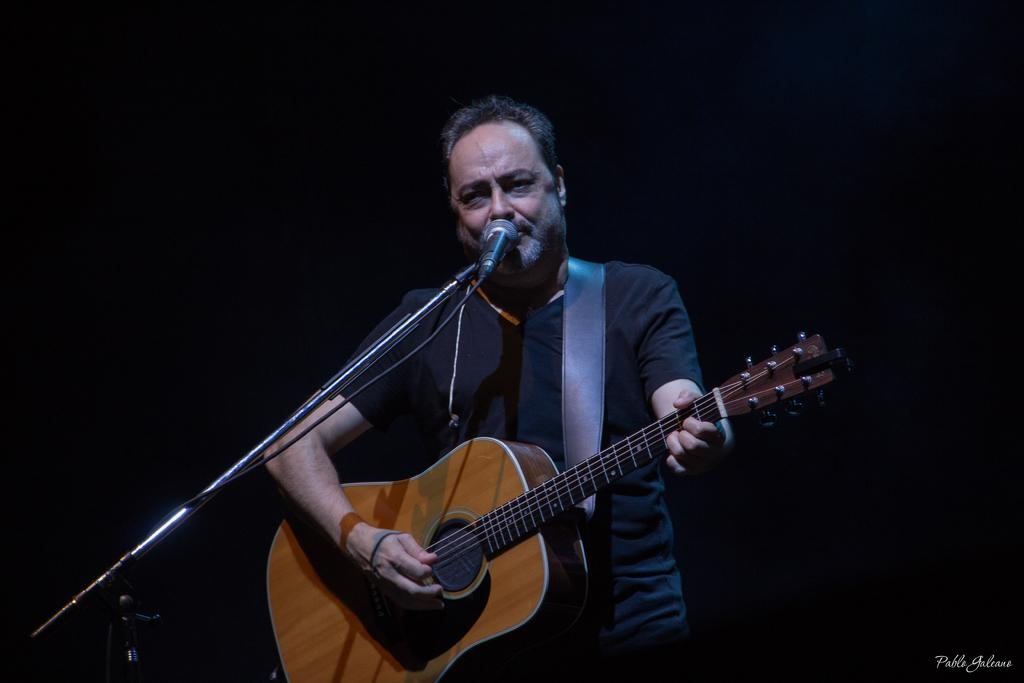What is the man in the image doing? The man is singing a song. What is the man holding in the image? The man is holding a guitar. What is the man wearing in the image? The man is wearing a black t-shirt. What is in front of the man in the image? There is a microphone with a stand in front of the man. What is the color of the background behind the man? The background behind the man is black. What type of meal is the man preparing in the image? There is no meal preparation visible in the image; the man is singing and holding a guitar. How many kittens are sitting on the man's lap in the image? There are no kittens present in the image. 